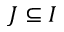Convert formula to latex. <formula><loc_0><loc_0><loc_500><loc_500>J \subseteq I</formula> 